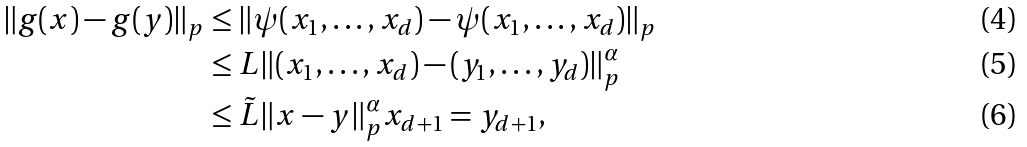<formula> <loc_0><loc_0><loc_500><loc_500>\| g ( x ) - g ( y ) \| _ { p } & \leq \| \psi ( x _ { 1 } , \dots , x _ { d } ) - \psi ( x _ { 1 } , \dots , x _ { d } ) \| _ { p } \\ & \leq L \| ( x _ { 1 } , \dots , x _ { d } ) - ( y _ { 1 } , \dots , y _ { d } ) \| _ { p } ^ { \alpha } \\ & \leq \tilde { L } \| x - y \| _ { p } ^ { \alpha } x _ { d + 1 } = y _ { d + 1 } ,</formula> 